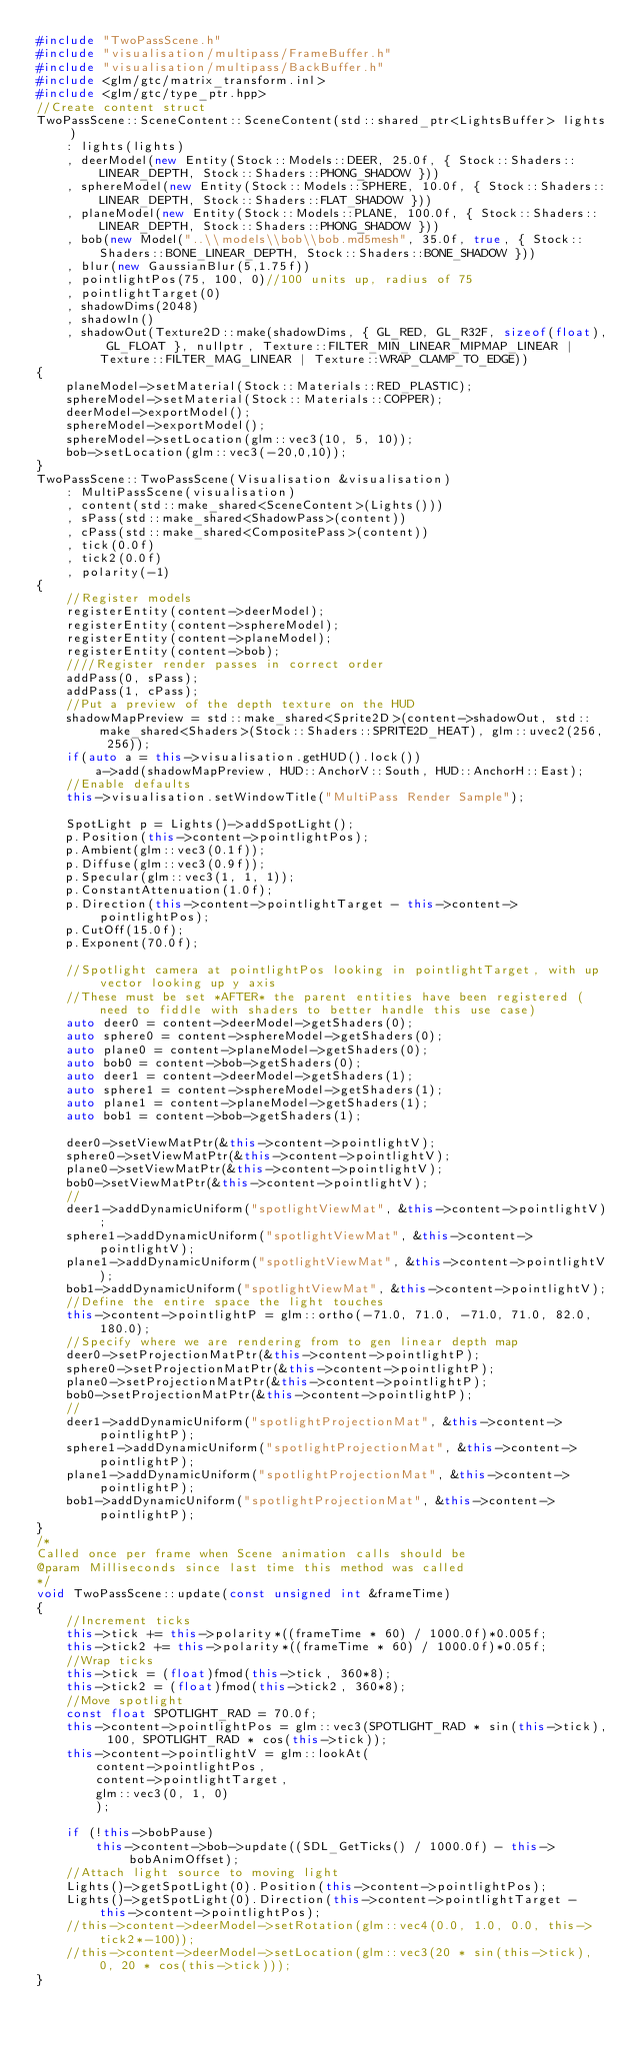Convert code to text. <code><loc_0><loc_0><loc_500><loc_500><_C++_>#include "TwoPassScene.h"
#include "visualisation/multipass/FrameBuffer.h"
#include "visualisation/multipass/BackBuffer.h"
#include <glm/gtc/matrix_transform.inl>
#include <glm/gtc/type_ptr.hpp>
//Create content struct
TwoPassScene::SceneContent::SceneContent(std::shared_ptr<LightsBuffer> lights)
	: lights(lights)
	, deerModel(new Entity(Stock::Models::DEER, 25.0f, { Stock::Shaders::LINEAR_DEPTH, Stock::Shaders::PHONG_SHADOW }))
    , sphereModel(new Entity(Stock::Models::SPHERE, 10.0f, { Stock::Shaders::LINEAR_DEPTH, Stock::Shaders::FLAT_SHADOW }))
    , planeModel(new Entity(Stock::Models::PLANE, 100.0f, { Stock::Shaders::LINEAR_DEPTH, Stock::Shaders::PHONG_SHADOW }))
	, bob(new Model("..\\models\\bob\\bob.md5mesh", 35.0f, true, { Stock::Shaders::BONE_LINEAR_DEPTH, Stock::Shaders::BONE_SHADOW }))
    , blur(new GaussianBlur(5,1.75f))
    , pointlightPos(75, 100, 0)//100 units up, radius of 75
    , pointlightTarget(0)
    , shadowDims(2048)
	, shadowIn()
    , shadowOut(Texture2D::make(shadowDims, { GL_RED, GL_R32F, sizeof(float), GL_FLOAT }, nullptr, Texture::FILTER_MIN_LINEAR_MIPMAP_LINEAR | Texture::FILTER_MAG_LINEAR | Texture::WRAP_CLAMP_TO_EDGE))
{
	planeModel->setMaterial(Stock::Materials::RED_PLASTIC);
	sphereModel->setMaterial(Stock::Materials::COPPER);
    deerModel->exportModel();
    sphereModel->exportModel();
    sphereModel->setLocation(glm::vec3(10, 5, 10));
	bob->setLocation(glm::vec3(-20,0,10));
}
TwoPassScene::TwoPassScene(Visualisation &visualisation)
	: MultiPassScene(visualisation)
	, content(std::make_shared<SceneContent>(Lights()))
    , sPass(std::make_shared<ShadowPass>(content))
    , cPass(std::make_shared<CompositePass>(content))
	, tick(0.0f)
	, tick2(0.0f)
	, polarity(-1)
{
	//Register models
    registerEntity(content->deerModel);
    registerEntity(content->sphereModel);
    registerEntity(content->planeModel);
	registerEntity(content->bob);
	////Register render passes in correct order
	addPass(0, sPass);
	addPass(1, cPass);
    //Put a preview of the depth texture on the HUD
	shadowMapPreview = std::make_shared<Sprite2D>(content->shadowOut, std::make_shared<Shaders>(Stock::Shaders::SPRITE2D_HEAT), glm::uvec2(256, 256));
    if(auto a = this->visualisation.getHUD().lock())
        a->add(shadowMapPreview, HUD::AnchorV::South, HUD::AnchorH::East);
	//Enable defaults
	this->visualisation.setWindowTitle("MultiPass Render Sample");

	SpotLight p = Lights()->addSpotLight();
	p.Position(this->content->pointlightPos);
	p.Ambient(glm::vec3(0.1f));
	p.Diffuse(glm::vec3(0.9f));
	p.Specular(glm::vec3(1, 1, 1));
	p.ConstantAttenuation(1.0f);
	p.Direction(this->content->pointlightTarget - this->content->pointlightPos);
	p.CutOff(15.0f);
	p.Exponent(70.0f);

    //Spotlight camera at pointlightPos looking in pointlightTarget, with up vector looking up y axis
    //These must be set *AFTER* the parent entities have been registered (need to fiddle with shaders to better handle this use case)
	auto deer0 = content->deerModel->getShaders(0);
	auto sphere0 = content->sphereModel->getShaders(0);
	auto plane0 = content->planeModel->getShaders(0);
	auto bob0 = content->bob->getShaders(0);
	auto deer1 = content->deerModel->getShaders(1);
	auto sphere1 = content->sphereModel->getShaders(1);
	auto plane1 = content->planeModel->getShaders(1);
	auto bob1 = content->bob->getShaders(1);

	deer0->setViewMatPtr(&this->content->pointlightV);
	sphere0->setViewMatPtr(&this->content->pointlightV);
	plane0->setViewMatPtr(&this->content->pointlightV);
	bob0->setViewMatPtr(&this->content->pointlightV);
	//
	deer1->addDynamicUniform("spotlightViewMat", &this->content->pointlightV);
	sphere1->addDynamicUniform("spotlightViewMat", &this->content->pointlightV);
	plane1->addDynamicUniform("spotlightViewMat", &this->content->pointlightV);
	bob1->addDynamicUniform("spotlightViewMat", &this->content->pointlightV);
    //Define the entire space the light touches
    this->content->pointlightP = glm::ortho(-71.0, 71.0, -71.0, 71.0, 82.0, 180.0);
	//Specify where we are rendering from to gen linear depth map
	deer0->setProjectionMatPtr(&this->content->pointlightP);
	sphere0->setProjectionMatPtr(&this->content->pointlightP);
	plane0->setProjectionMatPtr(&this->content->pointlightP);
	bob0->setProjectionMatPtr(&this->content->pointlightP);
	//
	deer1->addDynamicUniform("spotlightProjectionMat", &this->content->pointlightP);
	sphere1->addDynamicUniform("spotlightProjectionMat", &this->content->pointlightP);
	plane1->addDynamicUniform("spotlightProjectionMat", &this->content->pointlightP);
	bob1->addDynamicUniform("spotlightProjectionMat", &this->content->pointlightP);
}
/*
Called once per frame when Scene animation calls should be
@param Milliseconds since last time this method was called
*/
void TwoPassScene::update(const unsigned int &frameTime)
{
    //Increment ticks
	this->tick += this->polarity*((frameTime * 60) / 1000.0f)*0.005f;
	this->tick2 += this->polarity*((frameTime * 60) / 1000.0f)*0.05f;
    //Wrap ticks
	this->tick = (float)fmod(this->tick, 360*8);
	this->tick2 = (float)fmod(this->tick2, 360*8);
    //Move spotlight
    const float SPOTLIGHT_RAD = 70.0f;
    this->content->pointlightPos = glm::vec3(SPOTLIGHT_RAD * sin(this->tick), 100, SPOTLIGHT_RAD * cos(this->tick));
    this->content->pointlightV = glm::lookAt(
        content->pointlightPos,
        content->pointlightTarget,
        glm::vec3(0, 1, 0)
        );

	if (!this->bobPause)
		this->content->bob->update((SDL_GetTicks() / 1000.0f) - this->bobAnimOffset);
	//Attach light source to moving light
	Lights()->getSpotLight(0).Position(this->content->pointlightPos);
	Lights()->getSpotLight(0).Direction(this->content->pointlightTarget - this->content->pointlightPos);
	//this->content->deerModel->setRotation(glm::vec4(0.0, 1.0, 0.0, this->tick2*-100));
	//this->content->deerModel->setLocation(glm::vec3(20 * sin(this->tick), 0, 20 * cos(this->tick)));
}
</code> 